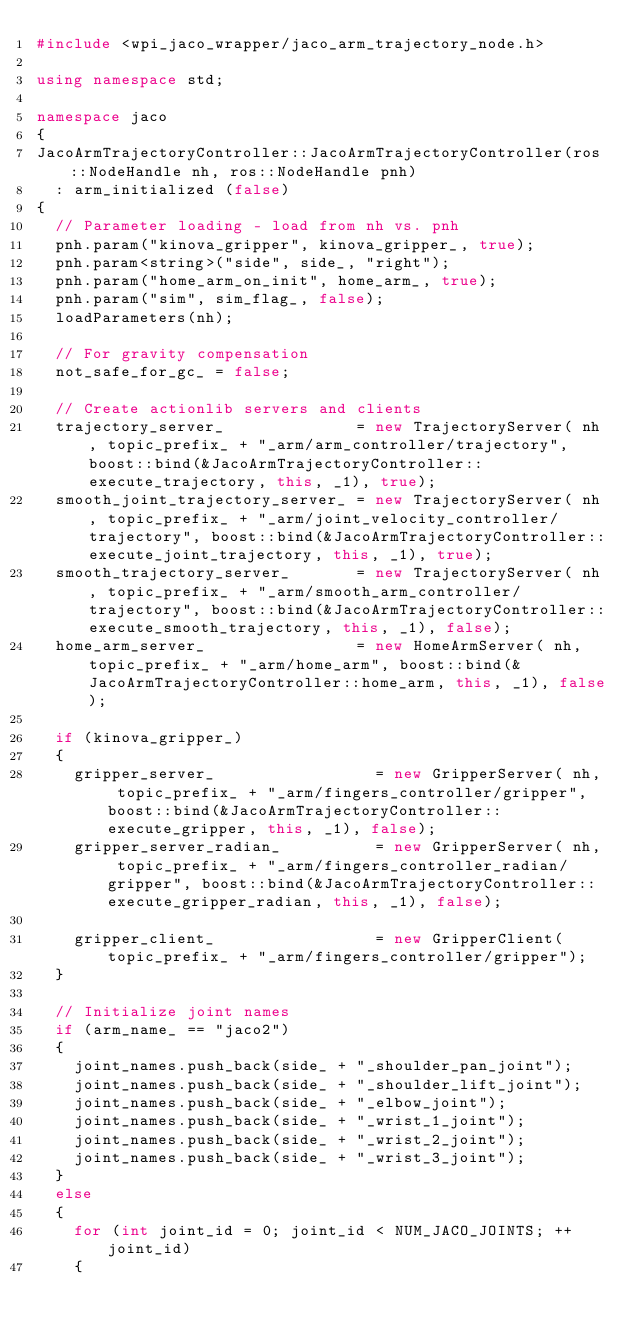<code> <loc_0><loc_0><loc_500><loc_500><_C++_>#include <wpi_jaco_wrapper/jaco_arm_trajectory_node.h>

using namespace std;

namespace jaco
{
JacoArmTrajectoryController::JacoArmTrajectoryController(ros::NodeHandle nh, ros::NodeHandle pnh)
  : arm_initialized (false)
{
  // Parameter loading - load from nh vs. pnh
  pnh.param("kinova_gripper", kinova_gripper_, true);
  pnh.param<string>("side", side_, "right");
  pnh.param("home_arm_on_init", home_arm_, true);
  pnh.param("sim", sim_flag_, false);
  loadParameters(nh);

  // For gravity compensation
  not_safe_for_gc_ = false;

  // Create actionlib servers and clients
  trajectory_server_              = new TrajectoryServer( nh, topic_prefix_ + "_arm/arm_controller/trajectory", boost::bind(&JacoArmTrajectoryController::execute_trajectory, this, _1), true);
  smooth_joint_trajectory_server_ = new TrajectoryServer( nh, topic_prefix_ + "_arm/joint_velocity_controller/trajectory", boost::bind(&JacoArmTrajectoryController::execute_joint_trajectory, this, _1), true);
  smooth_trajectory_server_       = new TrajectoryServer( nh, topic_prefix_ + "_arm/smooth_arm_controller/trajectory", boost::bind(&JacoArmTrajectoryController::execute_smooth_trajectory, this, _1), false);
  home_arm_server_                = new HomeArmServer( nh, topic_prefix_ + "_arm/home_arm", boost::bind(&JacoArmTrajectoryController::home_arm, this, _1), false);

  if (kinova_gripper_)
  {
    gripper_server_                 = new GripperServer( nh, topic_prefix_ + "_arm/fingers_controller/gripper", boost::bind(&JacoArmTrajectoryController::execute_gripper, this, _1), false);
    gripper_server_radian_          = new GripperServer( nh, topic_prefix_ + "_arm/fingers_controller_radian/gripper", boost::bind(&JacoArmTrajectoryController::execute_gripper_radian, this, _1), false);

    gripper_client_                 = new GripperClient( topic_prefix_ + "_arm/fingers_controller/gripper");
  }

  // Initialize joint names
  if (arm_name_ == "jaco2")
  {
    joint_names.push_back(side_ + "_shoulder_pan_joint");
    joint_names.push_back(side_ + "_shoulder_lift_joint");
    joint_names.push_back(side_ + "_elbow_joint");
    joint_names.push_back(side_ + "_wrist_1_joint");
    joint_names.push_back(side_ + "_wrist_2_joint");
    joint_names.push_back(side_ + "_wrist_3_joint");
  }
  else
  {
    for (int joint_id = 0; joint_id < NUM_JACO_JOINTS; ++joint_id)
    {</code> 